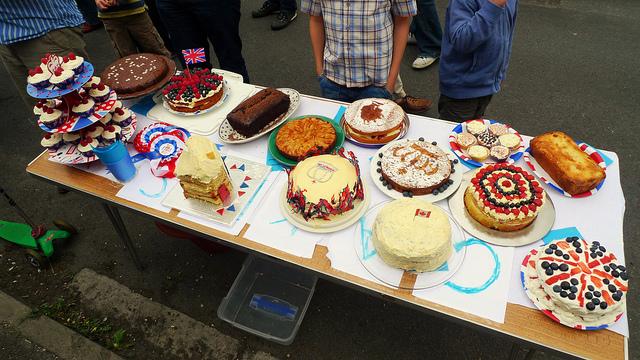Is this healthy food?
Keep it brief. No. How are the cakes packed?
Be succinct. On plates. How many variety of fruit are pictured?
Answer briefly. 2. What color icing do the cupcakes have?
Write a very short answer. White. What color is the table?
Be succinct. Brown. Are these plates full of food?
Answer briefly. Yes. Is the person in the purple top male or female?
Concise answer only. Male. What color is the star?
Short answer required. Red. How many people will be dining?
Quick response, please. 10. What type of food is pictured?
Be succinct. Cake. Is there anything healthy to eat on the table?
Answer briefly. No. What does the cake on the far right represent?
Quick response, please. Star. How many colors are the cupcakes?
Answer briefly. 3. What pastries are offered?
Give a very brief answer. Cakes. What color is the tray the candle holders are on?
Answer briefly. White. 